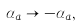<formula> <loc_0><loc_0><loc_500><loc_500>\alpha _ { a } \to - \alpha _ { a } ,</formula> 